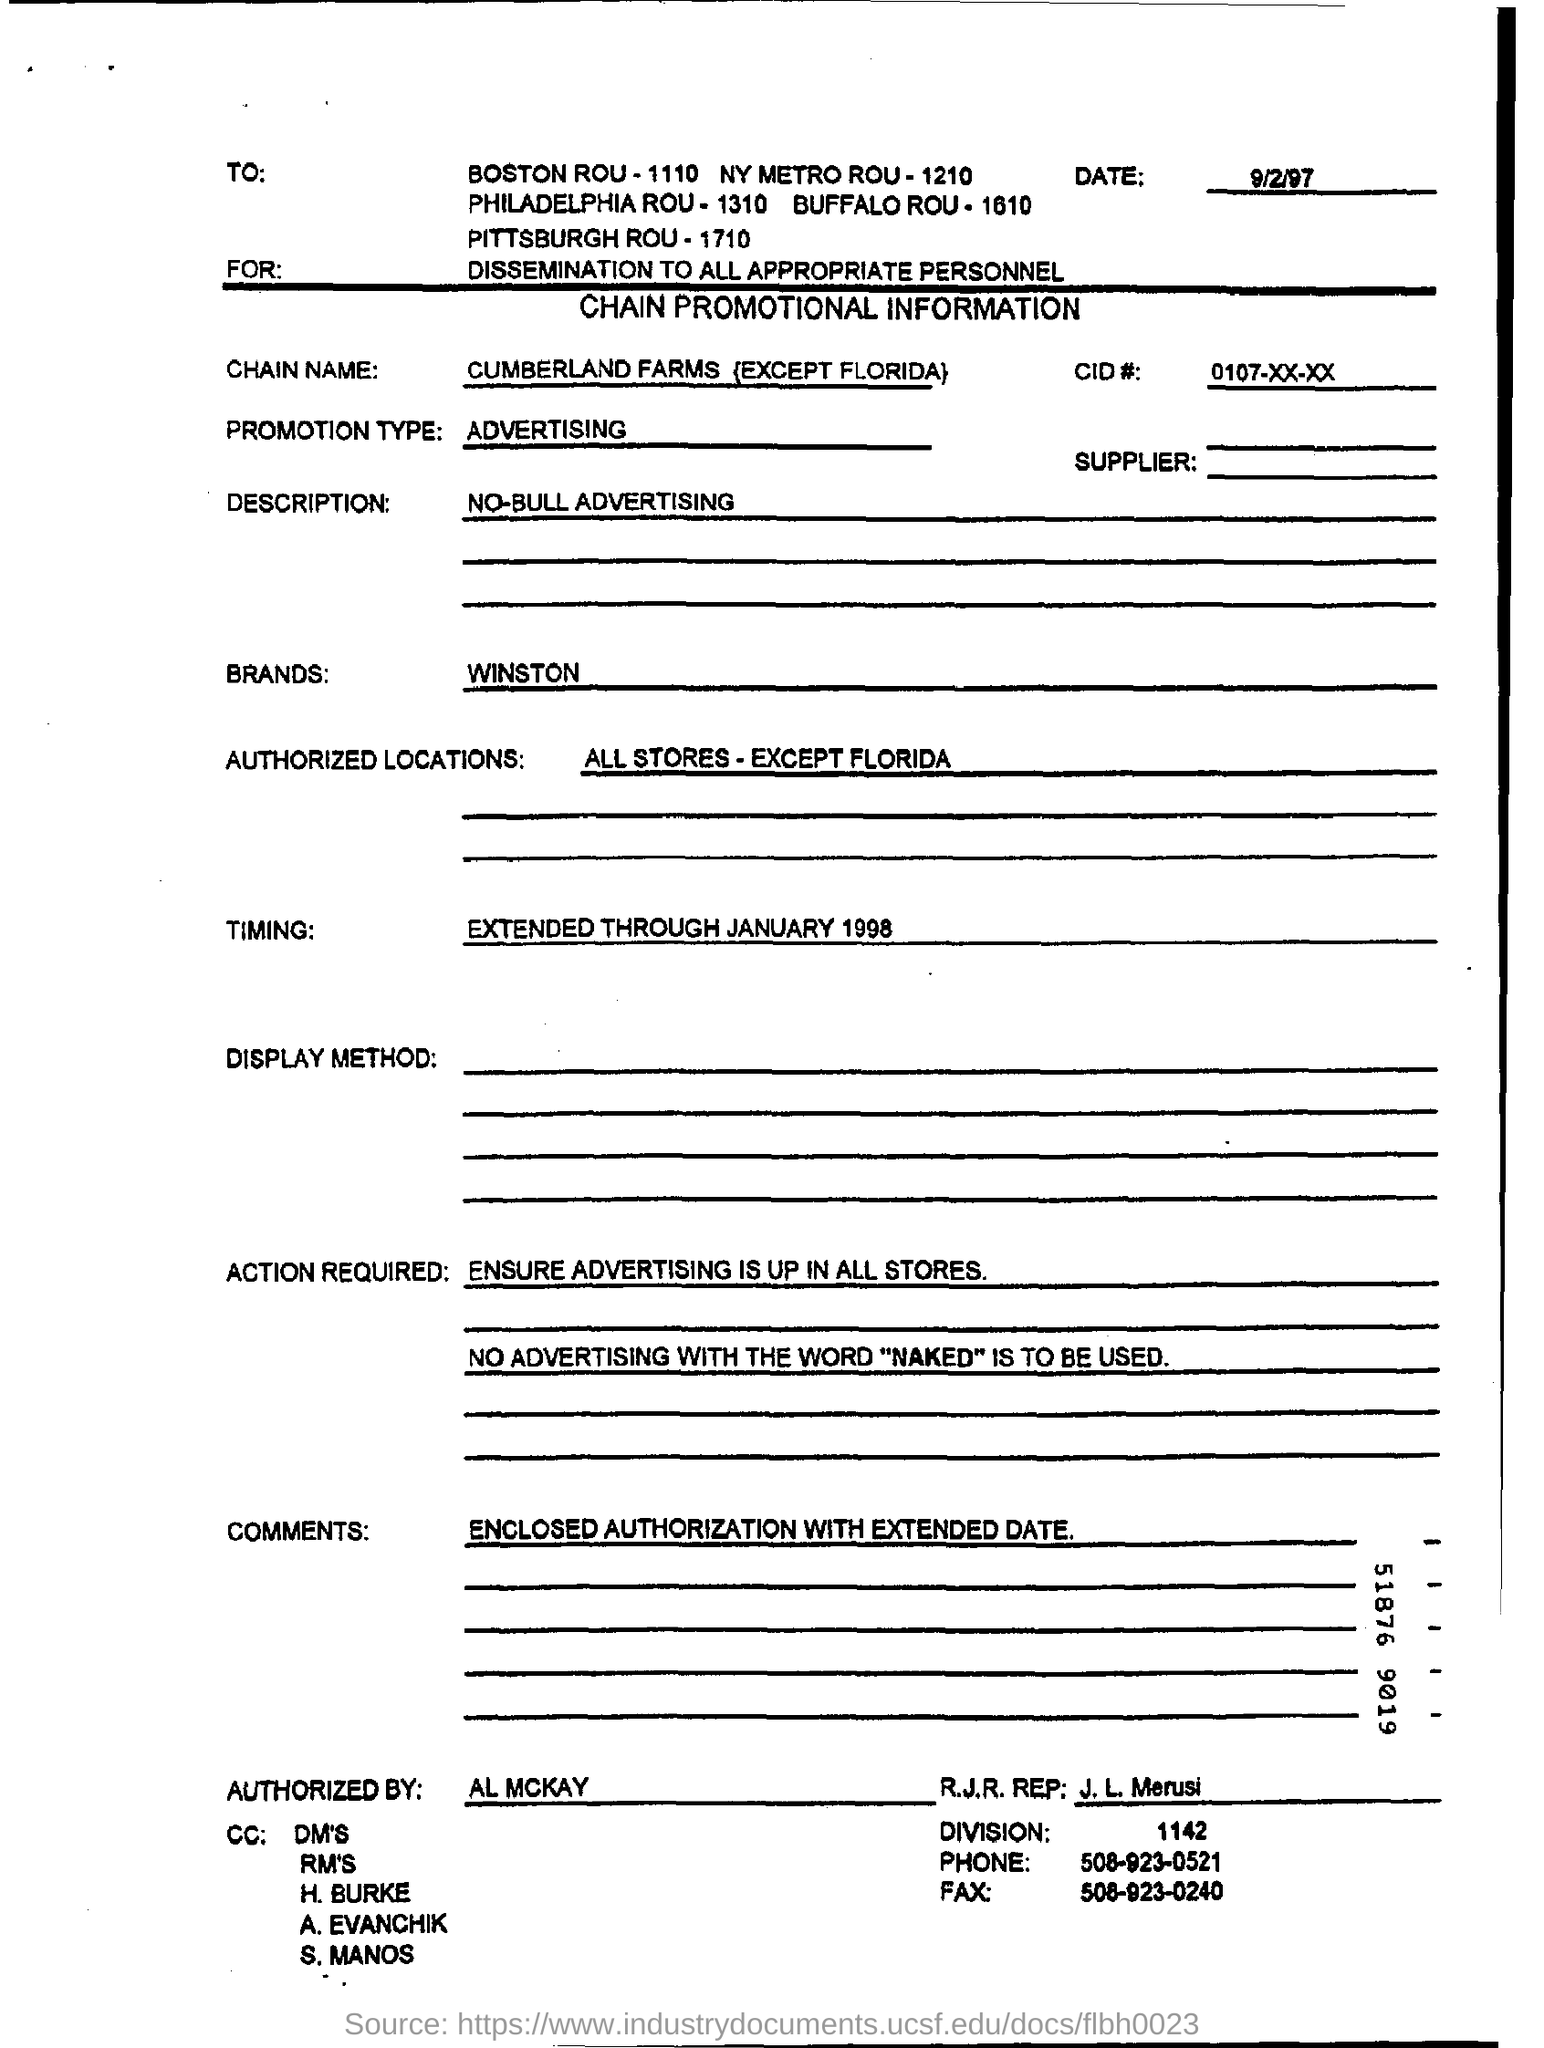Mention a couple of crucial points in this snapshot. I, AL MCKAY, have authorized this form. The promotion mentioned on the form is ADVERTISING. The chain promotional information form is dated September 2, 1997. The extended time mentioned on the form is "EXTENDED THROUGH JANUARY 1998. The word 'NAKED' is prohibited in the advertisement. 